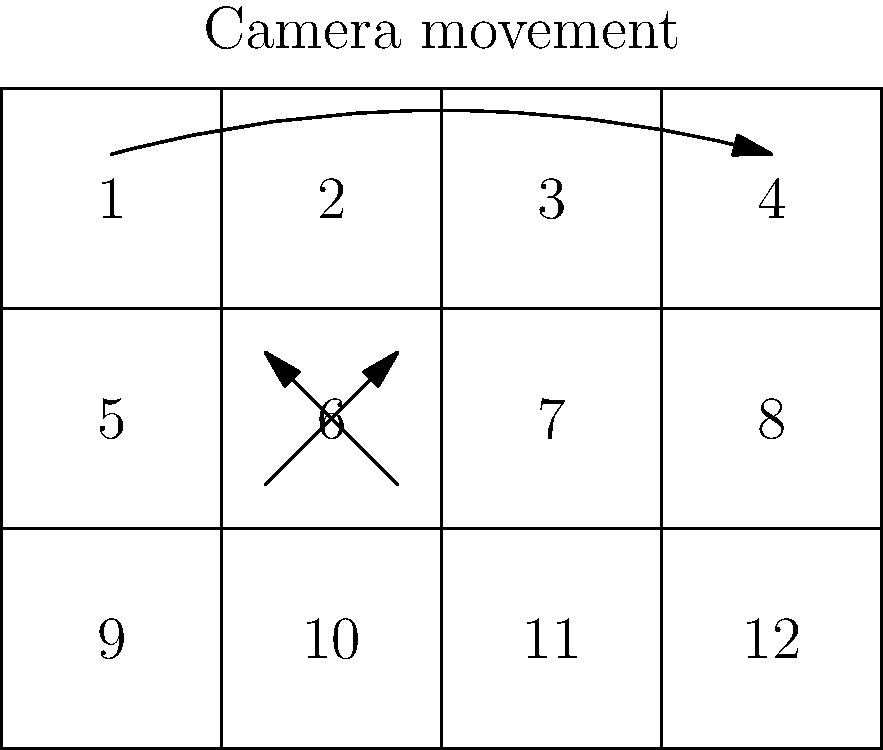In storyboarding a complex sword fight sequence for your independent film inspired by "Highlander," you've created a 12-panel storyboard as shown. Panel 6 depicts a crucial moment where two swords clash. How would you effectively convey the intensity and importance of this moment through camera movement and shot composition across panels 4, 5, and 6? To effectively convey the intensity and importance of the sword clash moment in panel 6, consider the following steps:

1. Panel 4: Establish the scene
   - Use a wide shot to show both characters in their fighting stances
   - Create tension through character positioning and body language

2. Panel 5: Build anticipation
   - Employ a medium shot or close-up of one character's face
   - Show determination or fear in their expression
   - Hint at the impending clash through character movement

3. Panel 6: Climactic moment
   - Use an extreme close-up of the swords clashing
   - Implement dynamic composition with diagonal lines for energy
   - Add motion lines or impact effects to emphasize the collision

4. Camera movement:
   - Utilize a gradual push-in from panel 4 to 6
   - Start wide in panel 4, move closer in panel 5, and end with the extreme close-up in panel 6
   - This movement creates a sense of escalating tension and draws the viewer into the action

5. Shot composition:
   - Panel 4: Rule of thirds for character placement
   - Panel 5: Asymmetrical framing to create unease
   - Panel 6: Central composition to focus on the clash

6. Lighting and contrast:
   - Increase contrast gradually from panel 4 to 6
   - Use dramatic lighting in panel 6 to highlight the swords

7. Sound design considerations:
   - Indicate building tension through sound effects or music cues
   - Plan for a momentary silence just before the clash in panel 6

By implementing these techniques across panels 4, 5, and 6, you create a mini-sequence that builds tension, focuses viewer attention, and emphasizes the crucial sword clash moment, elevating its importance within the overall action sequence.
Answer: Gradual push-in, increasing close-ups, central clash composition 